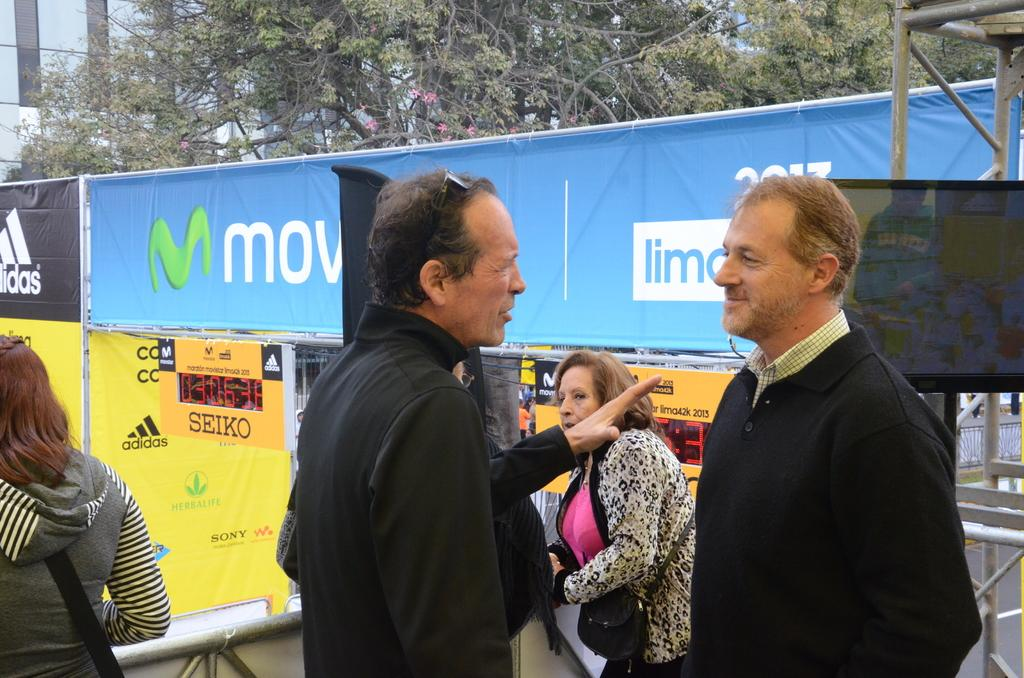What is the main subject of the image? The main subject of the image is people standing in the middle. What structures can be seen behind the people? There are tents visible behind the people. What type of natural elements are present in the image? Trees are present at the top of the image. What type of man-made structures are visible behind the trees? Buildings are visible behind the trees. Can you tell me who won the argument between the spies in the image? There are no spies or arguments present in the image; it features people standing in the middle with tents, trees, and buildings visible in the background. 